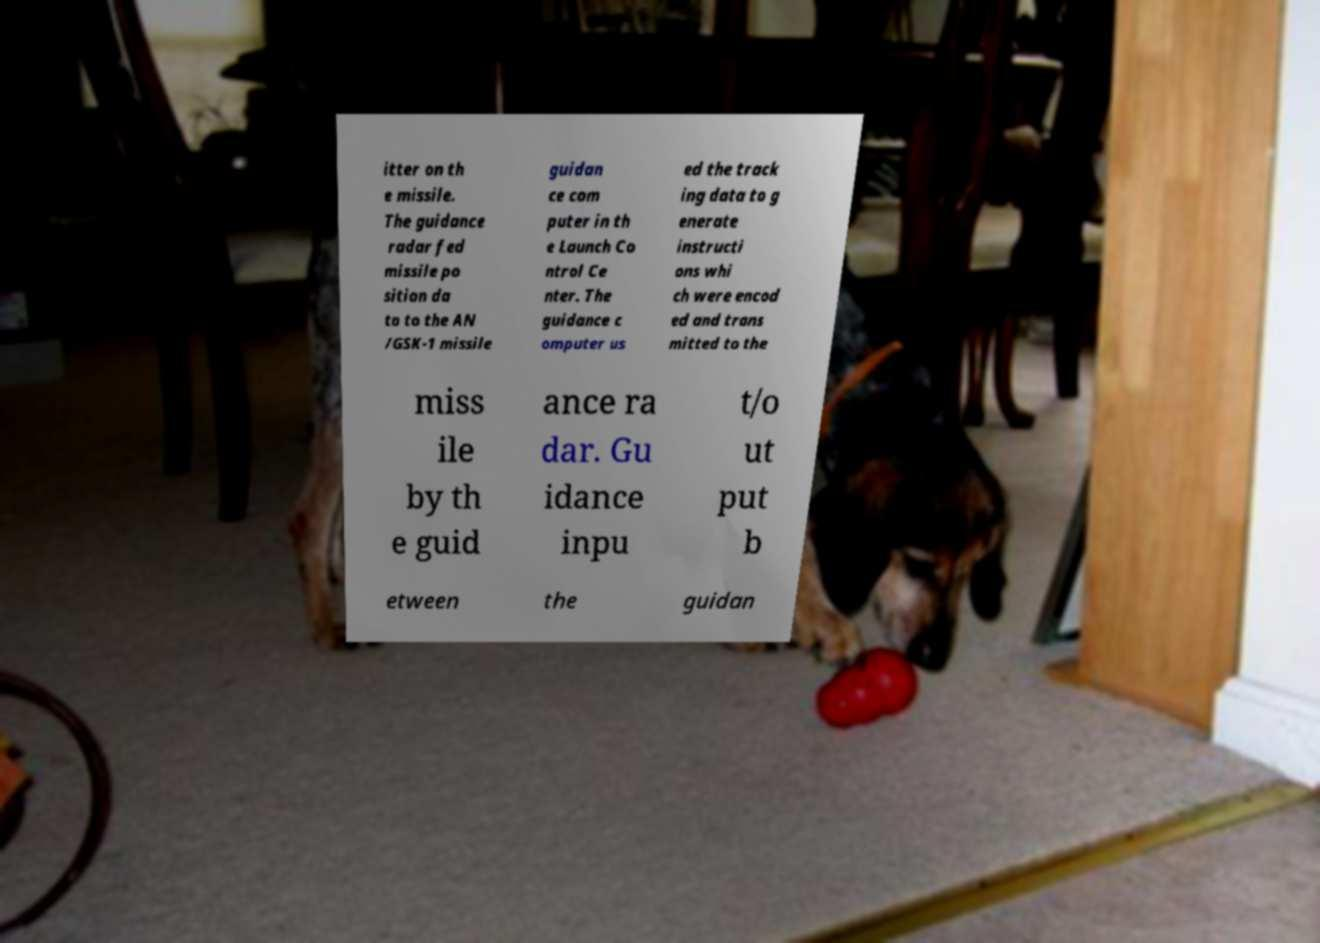For documentation purposes, I need the text within this image transcribed. Could you provide that? itter on th e missile. The guidance radar fed missile po sition da ta to the AN /GSK-1 missile guidan ce com puter in th e Launch Co ntrol Ce nter. The guidance c omputer us ed the track ing data to g enerate instructi ons whi ch were encod ed and trans mitted to the miss ile by th e guid ance ra dar. Gu idance inpu t/o ut put b etween the guidan 